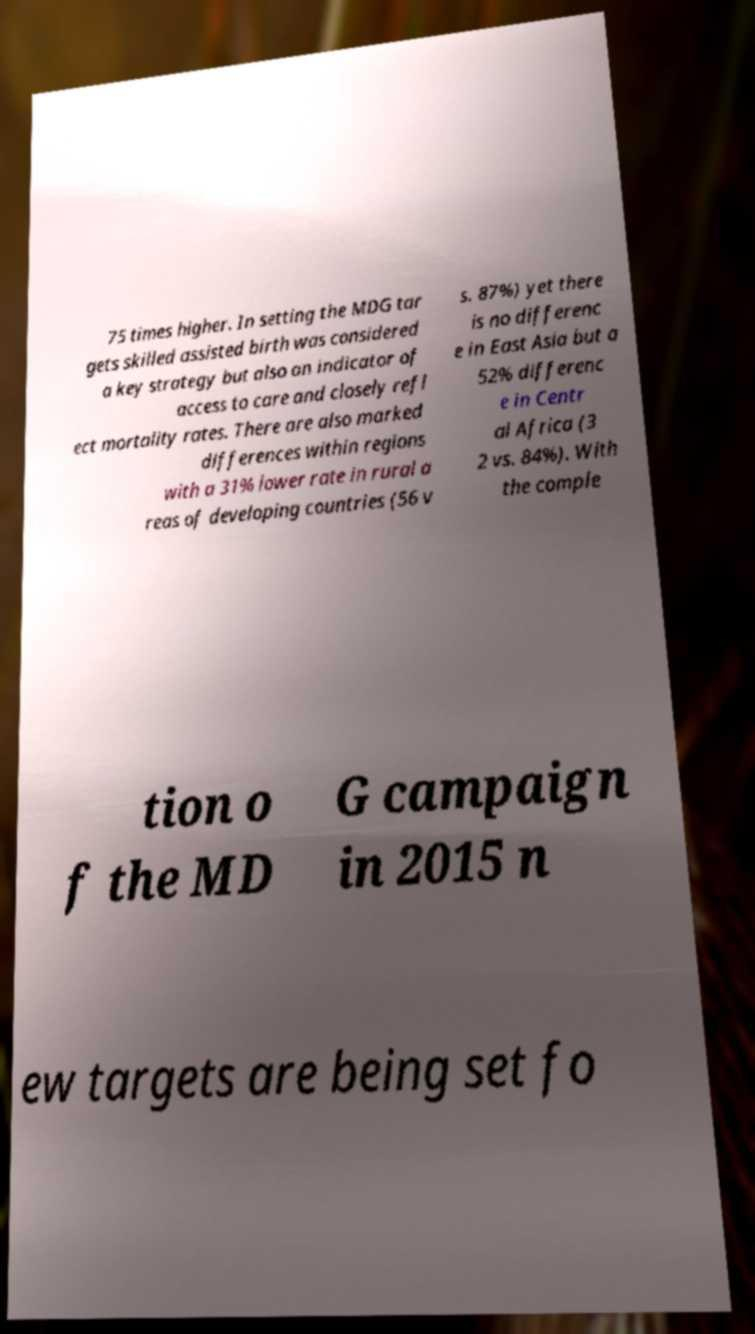Could you extract and type out the text from this image? 75 times higher. In setting the MDG tar gets skilled assisted birth was considered a key strategy but also an indicator of access to care and closely refl ect mortality rates. There are also marked differences within regions with a 31% lower rate in rural a reas of developing countries (56 v s. 87%) yet there is no differenc e in East Asia but a 52% differenc e in Centr al Africa (3 2 vs. 84%). With the comple tion o f the MD G campaign in 2015 n ew targets are being set fo 